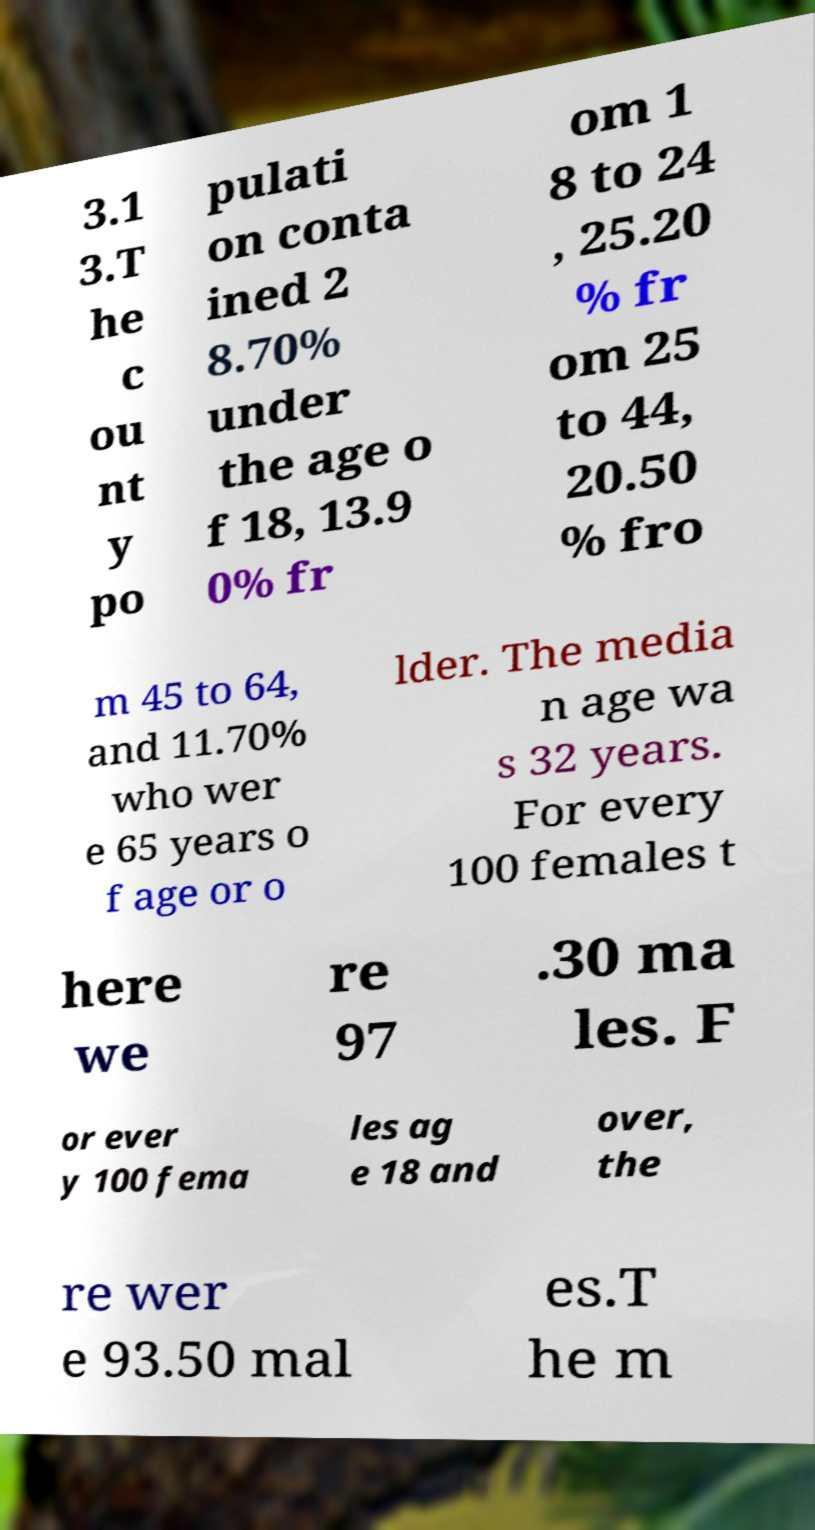I need the written content from this picture converted into text. Can you do that? 3.1 3.T he c ou nt y po pulati on conta ined 2 8.70% under the age o f 18, 13.9 0% fr om 1 8 to 24 , 25.20 % fr om 25 to 44, 20.50 % fro m 45 to 64, and 11.70% who wer e 65 years o f age or o lder. The media n age wa s 32 years. For every 100 females t here we re 97 .30 ma les. F or ever y 100 fema les ag e 18 and over, the re wer e 93.50 mal es.T he m 